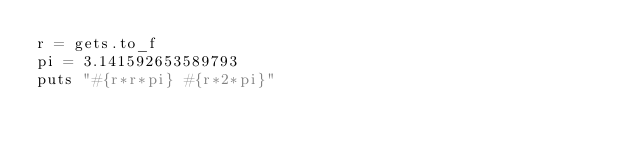<code> <loc_0><loc_0><loc_500><loc_500><_Ruby_>r = gets.to_f
pi = 3.141592653589793	
puts "#{r*r*pi} #{r*2*pi}"</code> 